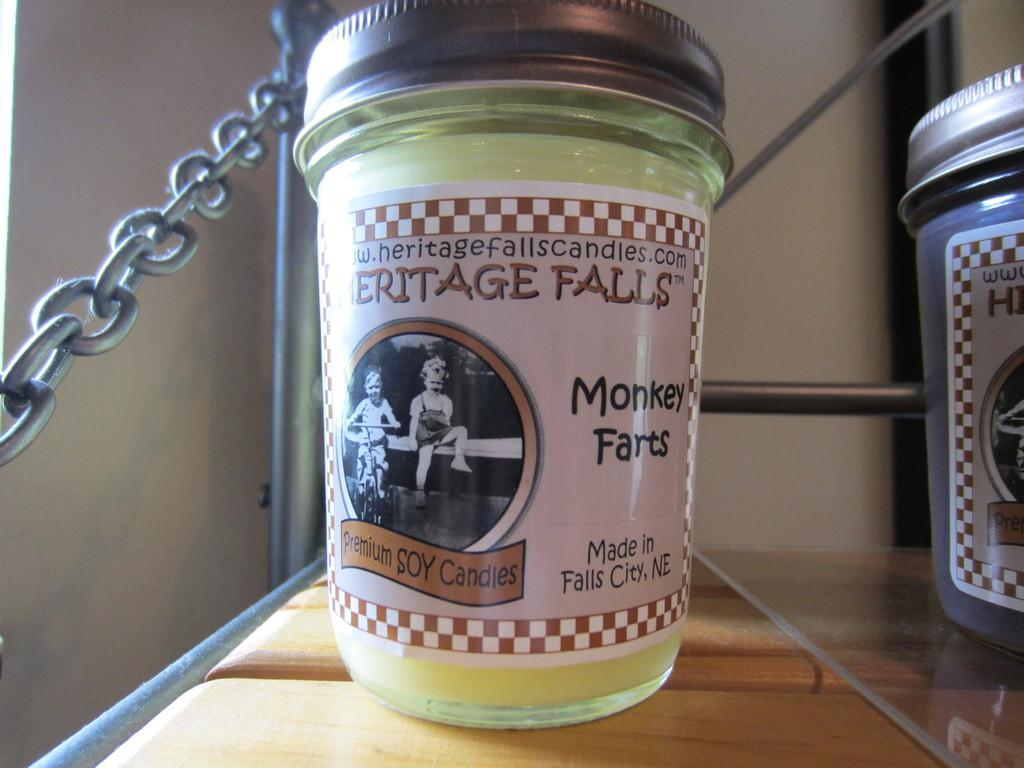<image>
Describe the image concisely. A jar made in falls city, NE that says Heritage Falls 